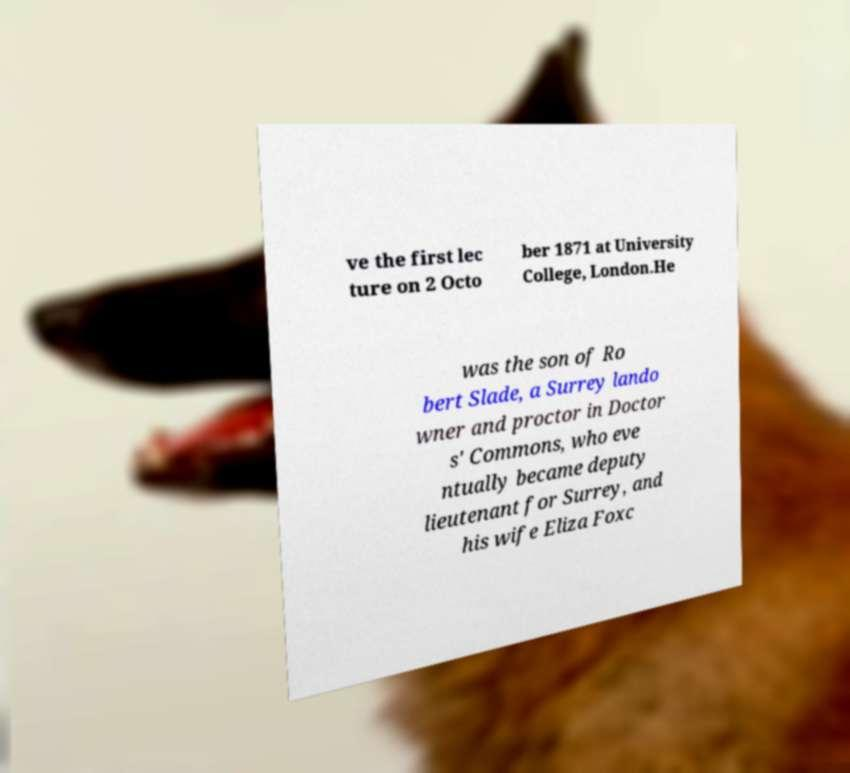For documentation purposes, I need the text within this image transcribed. Could you provide that? ve the first lec ture on 2 Octo ber 1871 at University College, London.He was the son of Ro bert Slade, a Surrey lando wner and proctor in Doctor s' Commons, who eve ntually became deputy lieutenant for Surrey, and his wife Eliza Foxc 